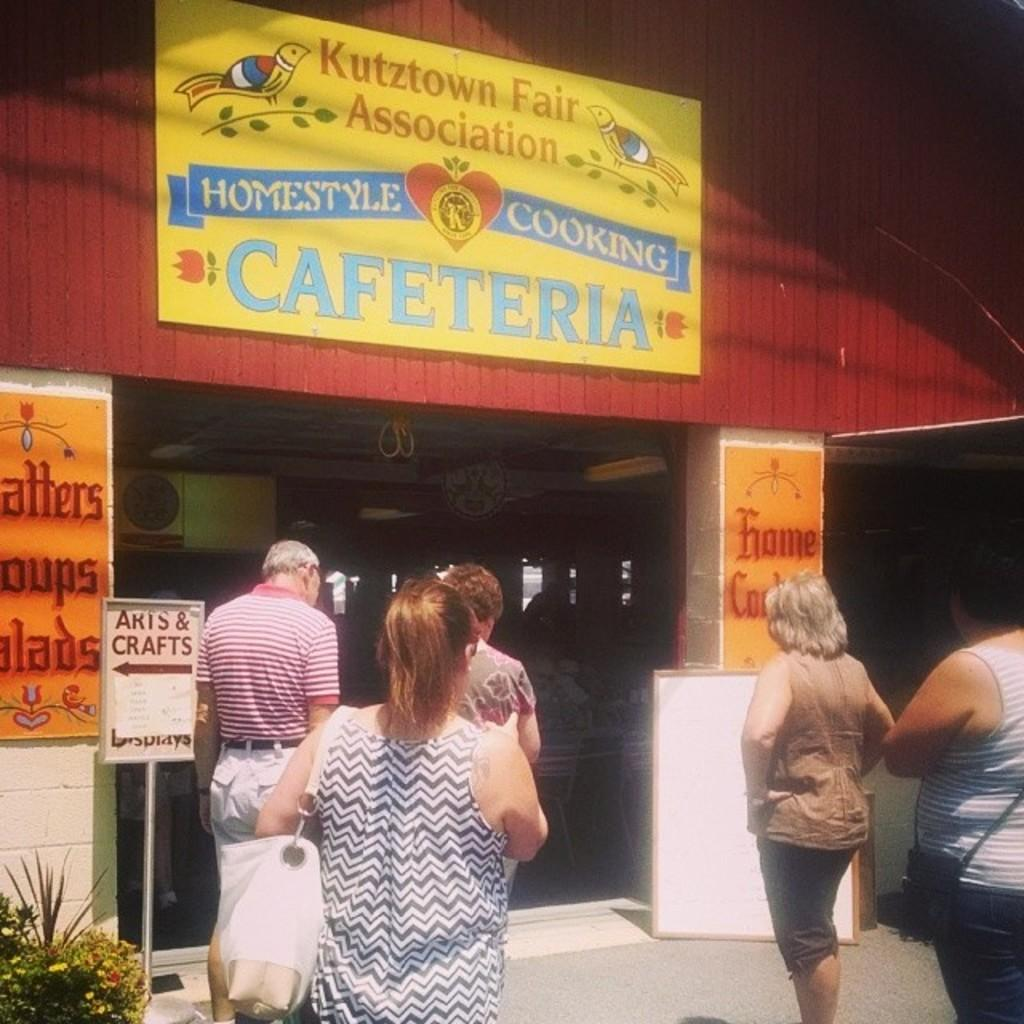Who or what can be seen in the image? There are people in the image. What type of objects are present in the image? There are boards, plants, flowers, a road, pillars, and a wall in the image. Can you describe the plants and flowers in the image? The image contains plants and flowers, but their specific types are not mentioned. What is the nature of the unspecified objects in the image? The other unspecified objects in the image are not described in detail. How many times does the person in the image whistle during the week? There is no information about whistling or the person's activities during the week in the image. What is the source of power for the objects in the image? The image does not provide information about the source of power for any objects. 